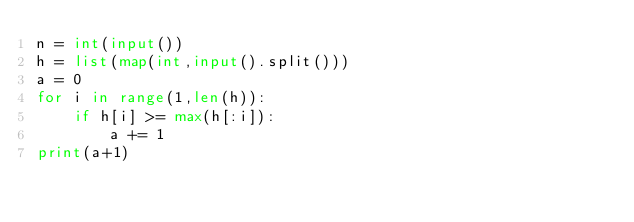<code> <loc_0><loc_0><loc_500><loc_500><_Python_>n = int(input())
h = list(map(int,input().split()))
a = 0
for i in range(1,len(h)):
    if h[i] >= max(h[:i]):
        a += 1
print(a+1)</code> 